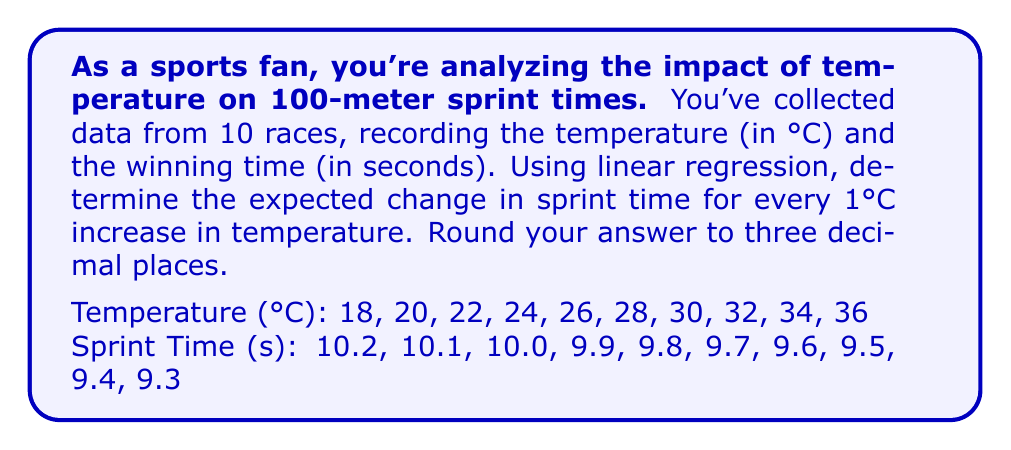Give your solution to this math problem. To solve this problem using linear regression, we'll follow these steps:

1. Calculate the means of temperature ($\bar{x}$) and sprint time ($\bar{y}$):
   $$\bar{x} = \frac{18 + 20 + 22 + 24 + 26 + 28 + 30 + 32 + 34 + 36}{10} = 27$$
   $$\bar{y} = \frac{10.2 + 10.1 + 10.0 + 9.9 + 9.8 + 9.7 + 9.6 + 9.5 + 9.4 + 9.3}{10} = 9.75$$

2. Calculate the sum of squares:
   $$S_{xx} = \sum(x_i - \bar{x})^2 = 660$$
   $$S_{xy} = \sum(x_i - \bar{x})(y_i - \bar{y}) = -33$$

3. Calculate the slope (b) of the regression line:
   $$b = \frac{S_{xy}}{S_{xx}} = \frac{-33}{660} = -0.05$$

4. The slope represents the change in sprint time for every 1°C increase in temperature.

5. Round the result to three decimal places: -0.050 seconds/°C.

This negative value indicates that as temperature increases, sprint times decrease (improve).
Answer: -0.050 seconds/°C 